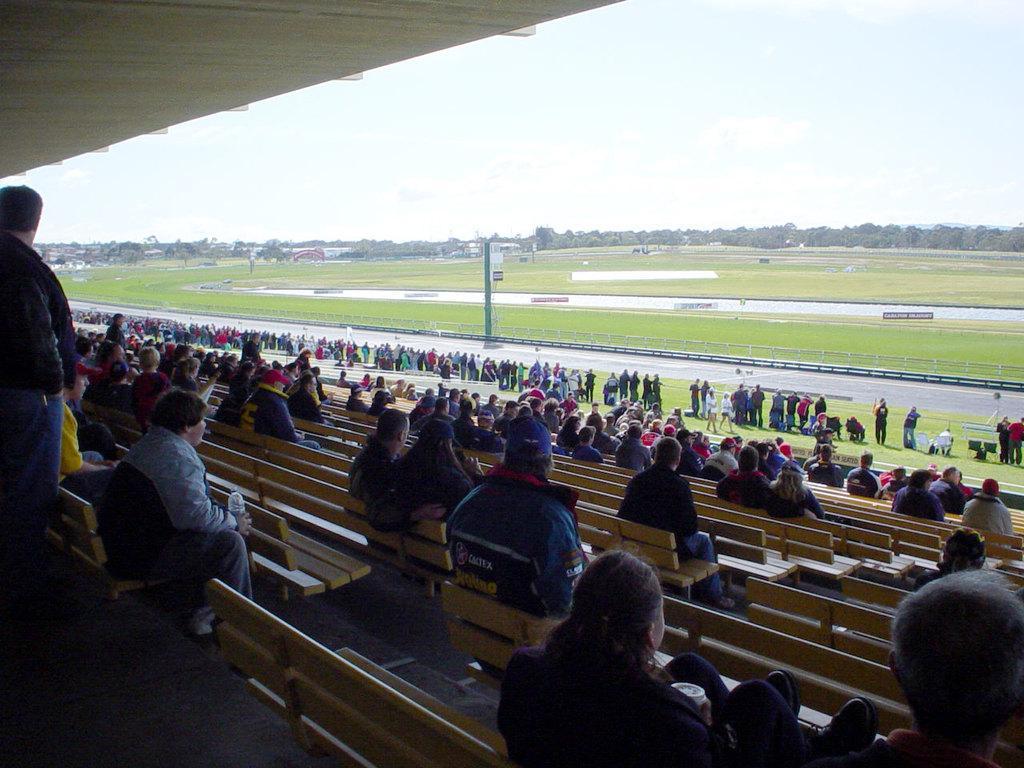Could you give a brief overview of what you see in this image? This image looks like a stadium, in this picture we can see a few people, among them some people are standing on the ground and some people are sitting on the benches, there are some boards with text and also we can see some trees, buildings and a pole, in the background we can see the sky. 